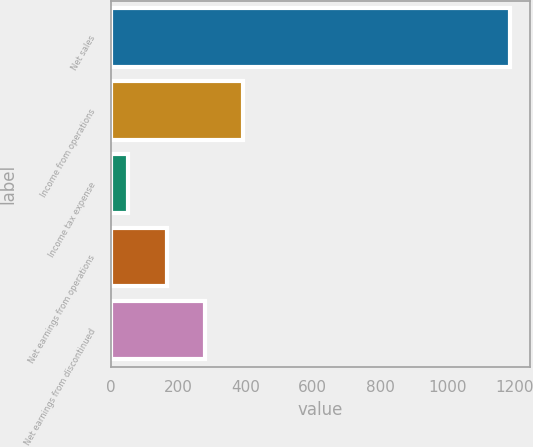Convert chart to OTSL. <chart><loc_0><loc_0><loc_500><loc_500><bar_chart><fcel>Net sales<fcel>Income from operations<fcel>Income tax expense<fcel>Net earnings from operations<fcel>Net earnings from discontinued<nl><fcel>1186<fcel>392.9<fcel>53<fcel>166.3<fcel>279.6<nl></chart> 